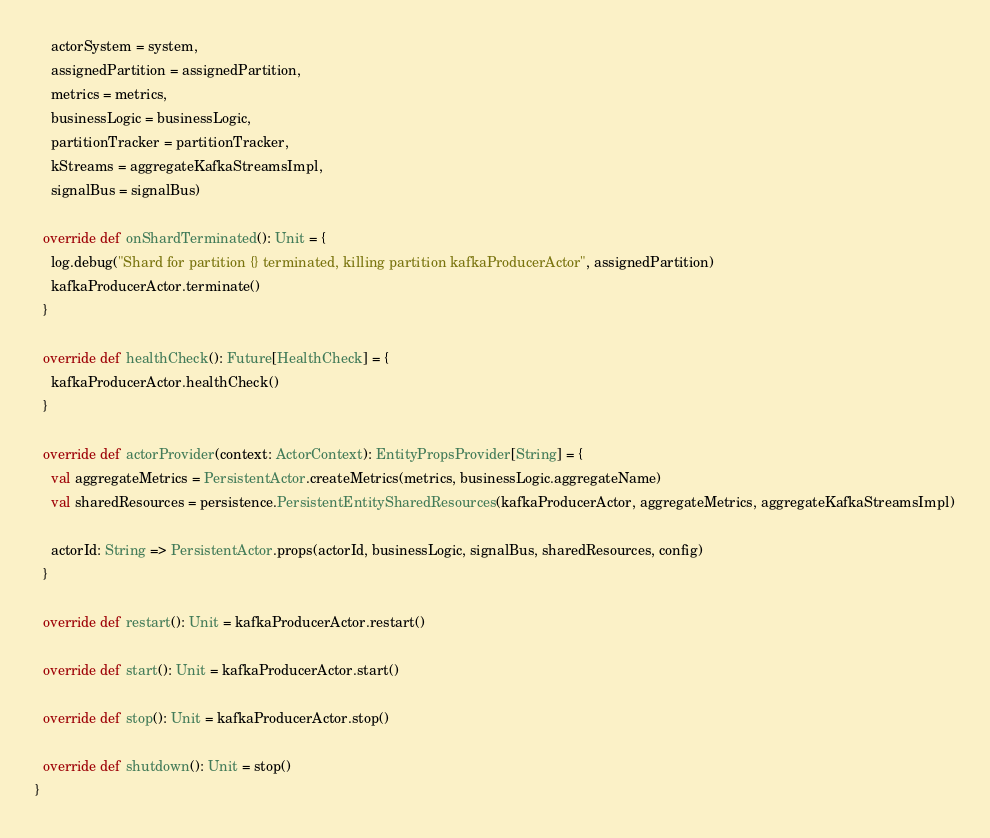<code> <loc_0><loc_0><loc_500><loc_500><_Scala_>    actorSystem = system,
    assignedPartition = assignedPartition,
    metrics = metrics,
    businessLogic = businessLogic,
    partitionTracker = partitionTracker,
    kStreams = aggregateKafkaStreamsImpl,
    signalBus = signalBus)

  override def onShardTerminated(): Unit = {
    log.debug("Shard for partition {} terminated, killing partition kafkaProducerActor", assignedPartition)
    kafkaProducerActor.terminate()
  }

  override def healthCheck(): Future[HealthCheck] = {
    kafkaProducerActor.healthCheck()
  }

  override def actorProvider(context: ActorContext): EntityPropsProvider[String] = {
    val aggregateMetrics = PersistentActor.createMetrics(metrics, businessLogic.aggregateName)
    val sharedResources = persistence.PersistentEntitySharedResources(kafkaProducerActor, aggregateMetrics, aggregateKafkaStreamsImpl)

    actorId: String => PersistentActor.props(actorId, businessLogic, signalBus, sharedResources, config)
  }

  override def restart(): Unit = kafkaProducerActor.restart()

  override def start(): Unit = kafkaProducerActor.start()

  override def stop(): Unit = kafkaProducerActor.stop()

  override def shutdown(): Unit = stop()
}
</code> 